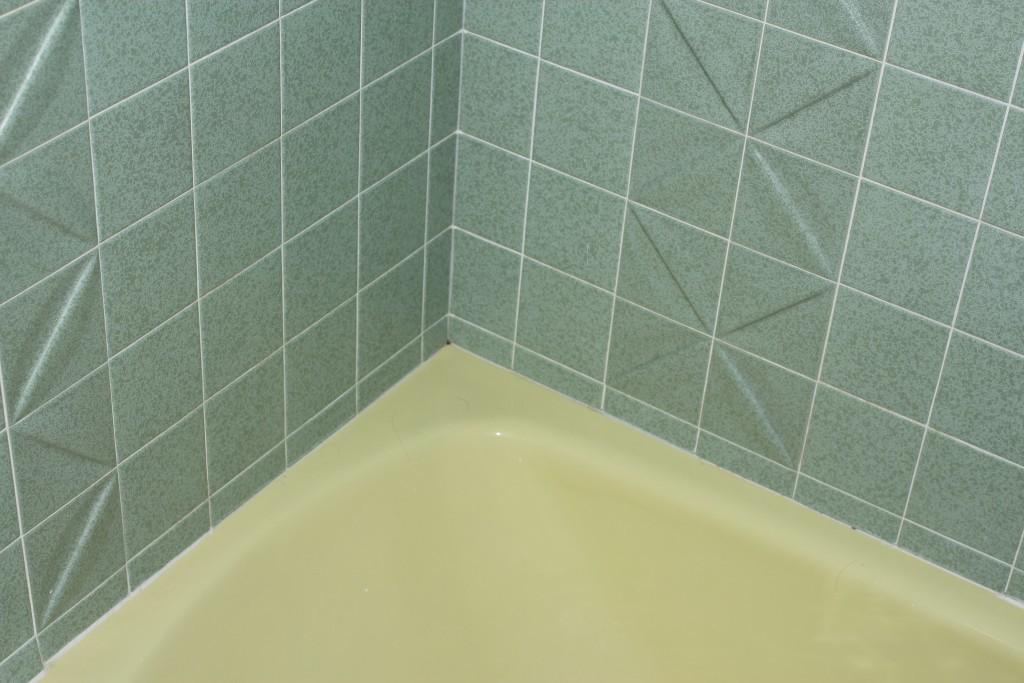How would you summarize this image in a sentence or two? i think this is a bathtub in a restroom. 